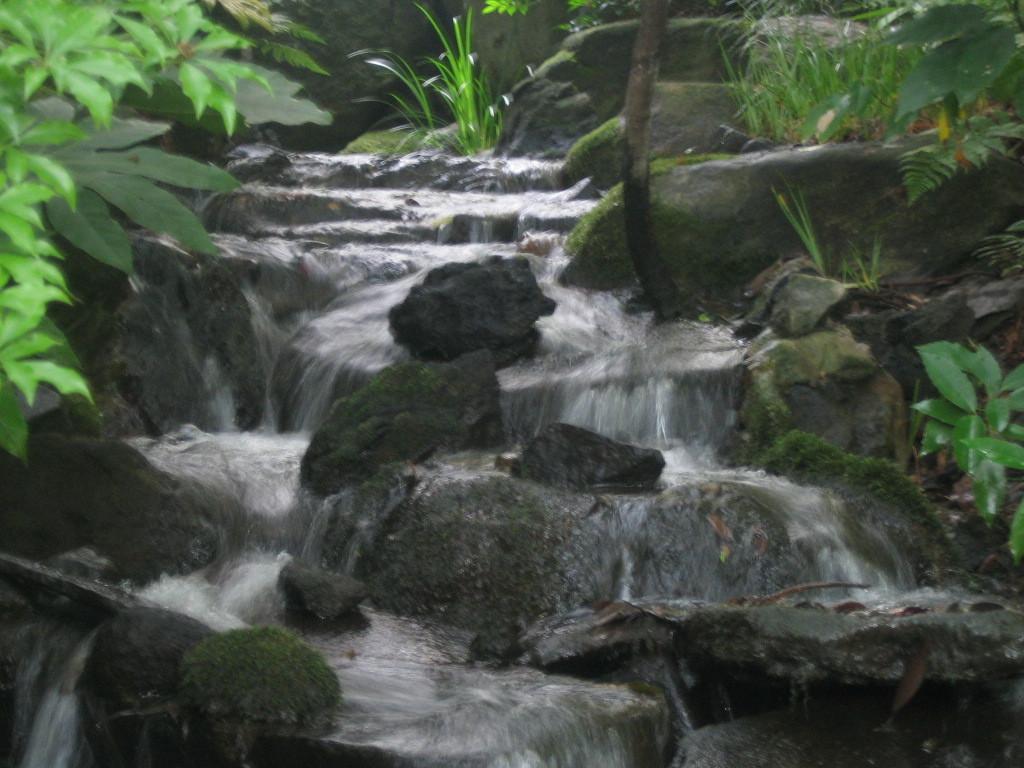Could you give a brief overview of what you see in this image? In this image I can see there are few rocks, water flowing and there are few plants at left and right side of the images. 